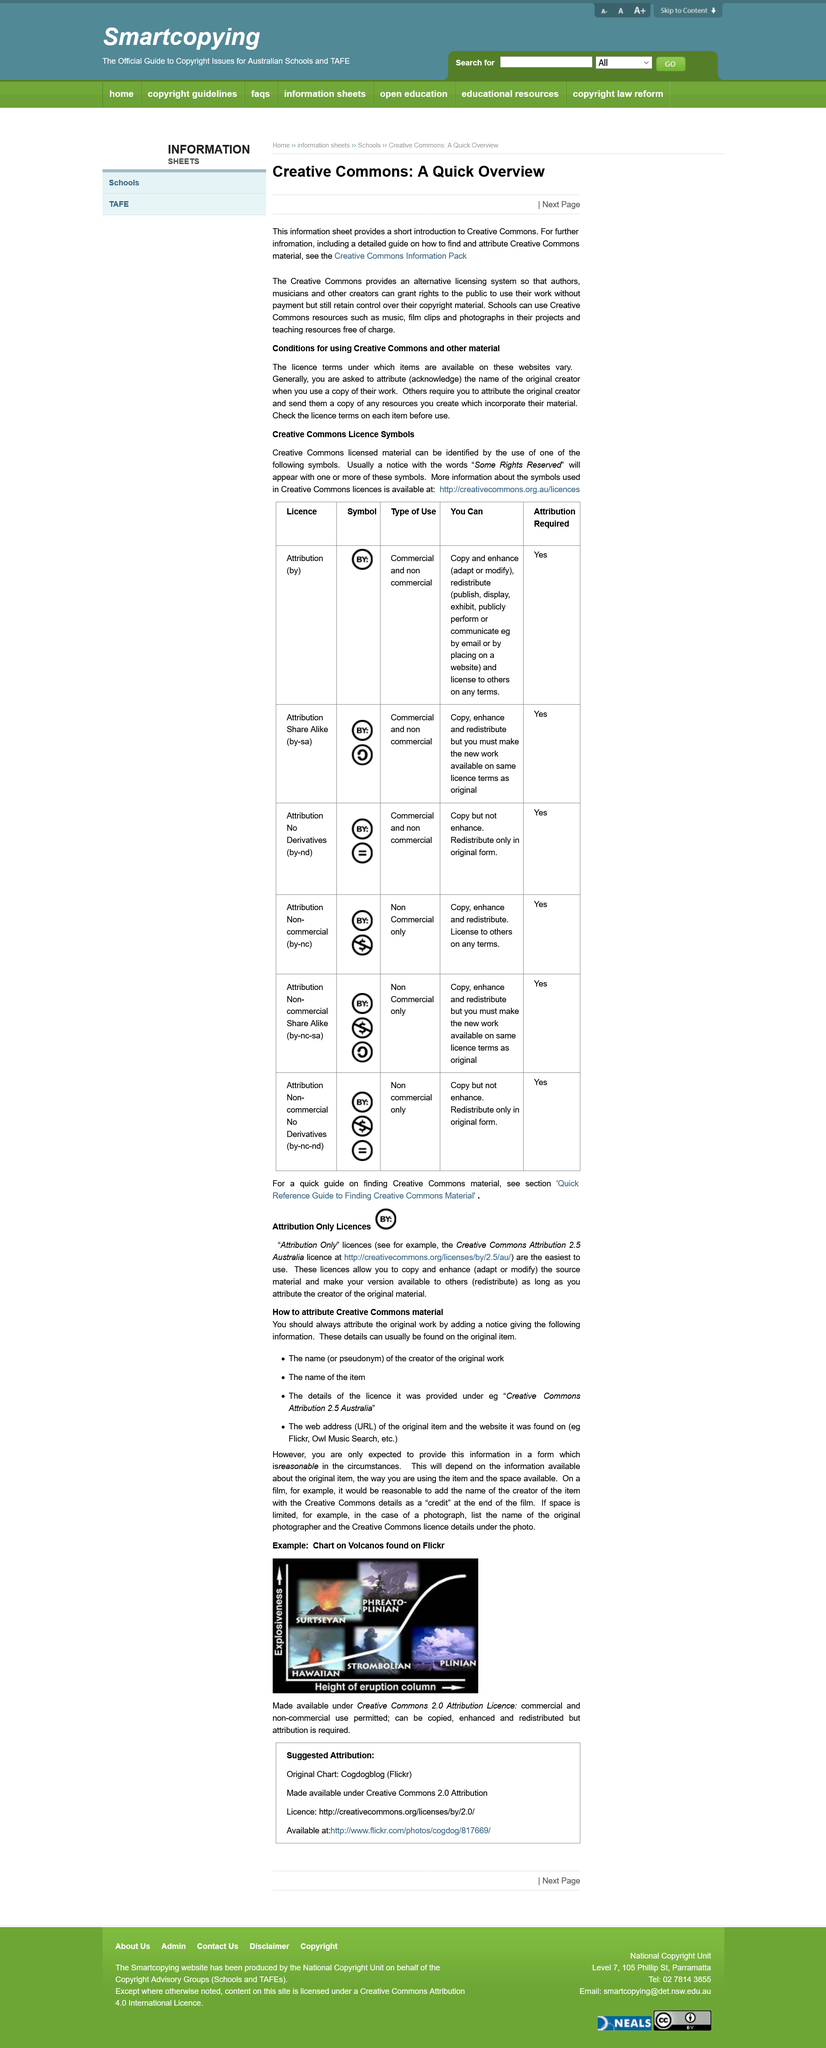Indicate a few pertinent items in this graphic. The title of this page is "Creative Commons: A quick Overview". This page is about Creative Commons, a non-profit organization that provides a standardized set of licenses for creators to allow others to share, use, and build upon their creative works, such as music, photos, and videos. The Creative Commons Attribution 2.5 Australia license is an example of an 'attribution only' license. Schools are allowed to use Creative Commons resources. Yes, all of the symbols require attribution. 